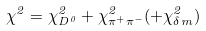<formula> <loc_0><loc_0><loc_500><loc_500>\chi ^ { 2 } = \chi ^ { 2 } _ { D ^ { 0 } } + \chi ^ { 2 } _ { \pi ^ { + } \pi ^ { - } } ( + \chi ^ { 2 } _ { \delta m } )</formula> 